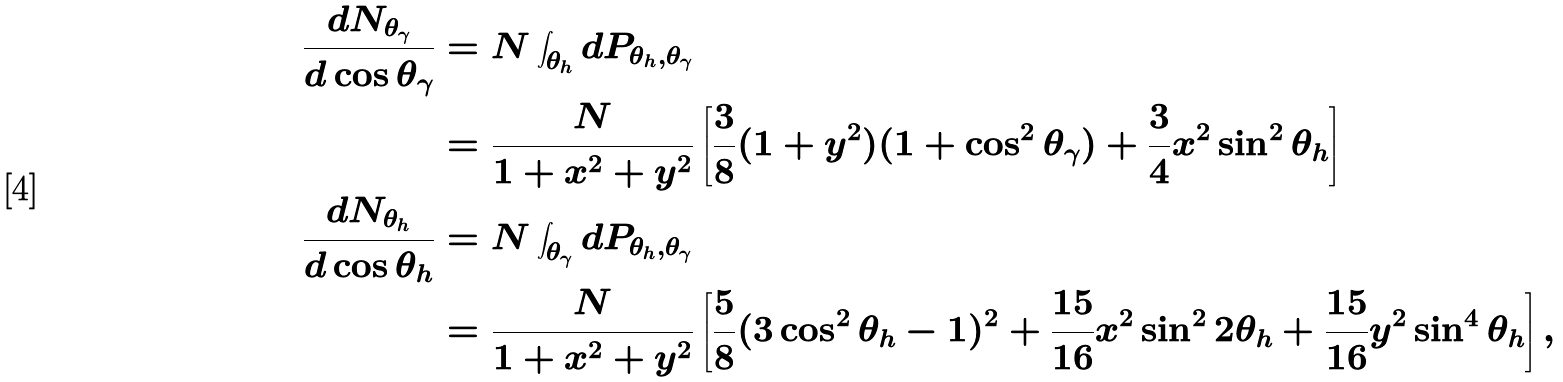Convert formula to latex. <formula><loc_0><loc_0><loc_500><loc_500>\frac { d N _ { \theta _ { \gamma } } } { d \cos \theta _ { \gamma } } & = N \int _ { \theta _ { h } } d P _ { \theta _ { h } , \theta _ { \gamma } } \\ & = \frac { N } { 1 + x ^ { 2 } + y ^ { 2 } } \left [ \frac { 3 } { 8 } ( 1 + y ^ { 2 } ) ( 1 + \cos ^ { 2 } \theta _ { \gamma } ) + \frac { 3 } { 4 } x ^ { 2 } \sin ^ { 2 } \theta _ { h } \right ] \\ \frac { d N _ { \theta _ { h } } } { d \cos \theta _ { h } } & = N \int _ { \theta _ { \gamma } } d P _ { \theta _ { h } , \theta _ { \gamma } } \\ & = \frac { N } { 1 + x ^ { 2 } + y ^ { 2 } } \left [ \frac { 5 } { 8 } ( 3 \cos ^ { 2 } \theta _ { h } - 1 ) ^ { 2 } + \frac { 1 5 } { 1 6 } x ^ { 2 } \sin ^ { 2 } 2 \theta _ { h } + \frac { 1 5 } { 1 6 } y ^ { 2 } \sin ^ { 4 } \theta _ { h } \right ] ,</formula> 